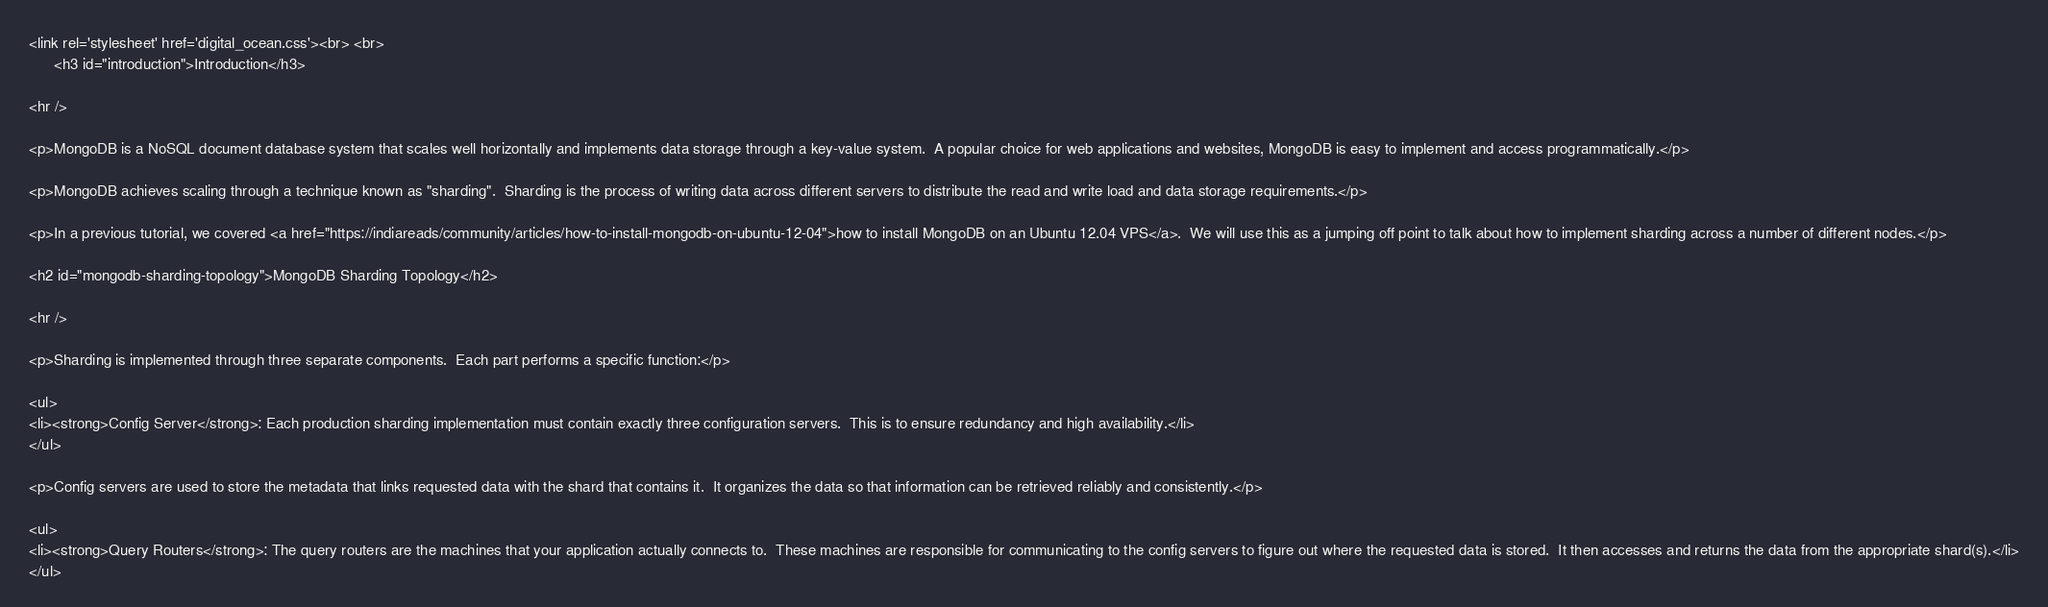<code> <loc_0><loc_0><loc_500><loc_500><_PHP_><link rel='stylesheet' href='digital_ocean.css'><br> <br> 
      <h3 id="introduction">Introduction</h3>

<hr />

<p>MongoDB is a NoSQL document database system that scales well horizontally and implements data storage through a key-value system.  A popular choice for web applications and websites, MongoDB is easy to implement and access programmatically.</p>

<p>MongoDB achieves scaling through a technique known as "sharding".  Sharding is the process of writing data across different servers to distribute the read and write load and data storage requirements.</p>

<p>In a previous tutorial, we covered <a href="https://indiareads/community/articles/how-to-install-mongodb-on-ubuntu-12-04">how to install MongoDB on an Ubuntu 12.04 VPS</a>.  We will use this as a jumping off point to talk about how to implement sharding across a number of different nodes.</p>

<h2 id="mongodb-sharding-topology">MongoDB Sharding Topology</h2>

<hr />

<p>Sharding is implemented through three separate components.  Each part performs a specific function:</p>

<ul>
<li><strong>Config Server</strong>: Each production sharding implementation must contain exactly three configuration servers.  This is to ensure redundancy and high availability.</li>
</ul>

<p>Config servers are used to store the metadata that links requested data with the shard that contains it.  It organizes the data so that information can be retrieved reliably and consistently.</p>

<ul>
<li><strong>Query Routers</strong>: The query routers are the machines that your application actually connects to.  These machines are responsible for communicating to the config servers to figure out where the requested data is stored.  It then accesses and returns the data from the appropriate shard(s).</li>
</ul>
</code> 